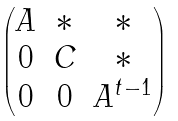Convert formula to latex. <formula><loc_0><loc_0><loc_500><loc_500>\begin{pmatrix} A & * & * \\ 0 & C & * \\ 0 & 0 & A ^ { t - 1 } \end{pmatrix}</formula> 